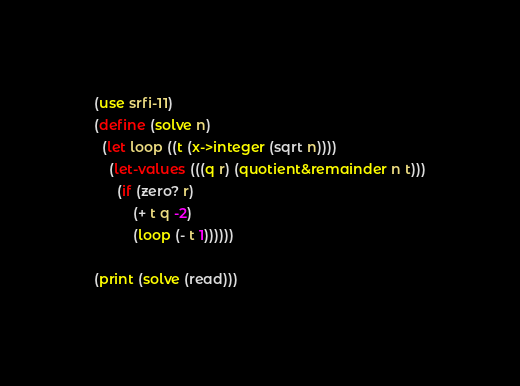Convert code to text. <code><loc_0><loc_0><loc_500><loc_500><_Scheme_>(use srfi-11)
(define (solve n)
  (let loop ((t (x->integer (sqrt n))))
    (let-values (((q r) (quotient&remainder n t)))
      (if (zero? r)
          (+ t q -2)
          (loop (- t 1))))))

(print (solve (read)))
</code> 